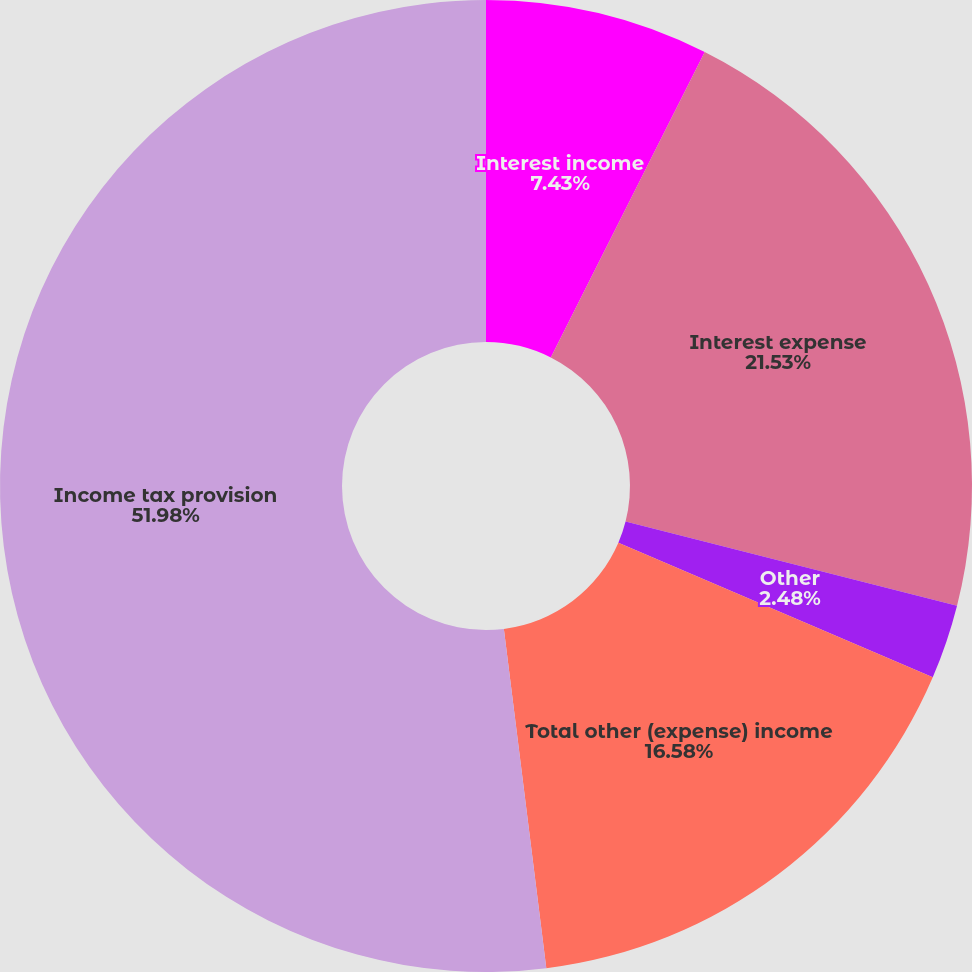Convert chart to OTSL. <chart><loc_0><loc_0><loc_500><loc_500><pie_chart><fcel>Interest income<fcel>Interest expense<fcel>Other<fcel>Total other (expense) income<fcel>Income tax provision<nl><fcel>7.43%<fcel>21.53%<fcel>2.48%<fcel>16.58%<fcel>51.98%<nl></chart> 